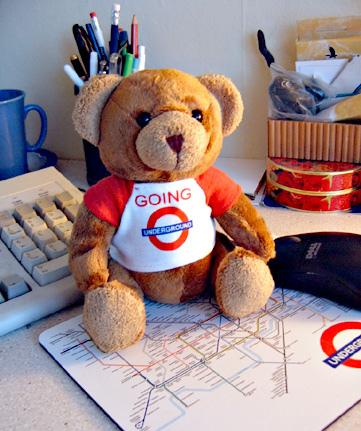What word begins with g ends in g on the bear?
Keep it brief. Going. What is the bear sitting on?
Answer briefly. Mouse pad. Is the bear alive?
Keep it brief. No. 